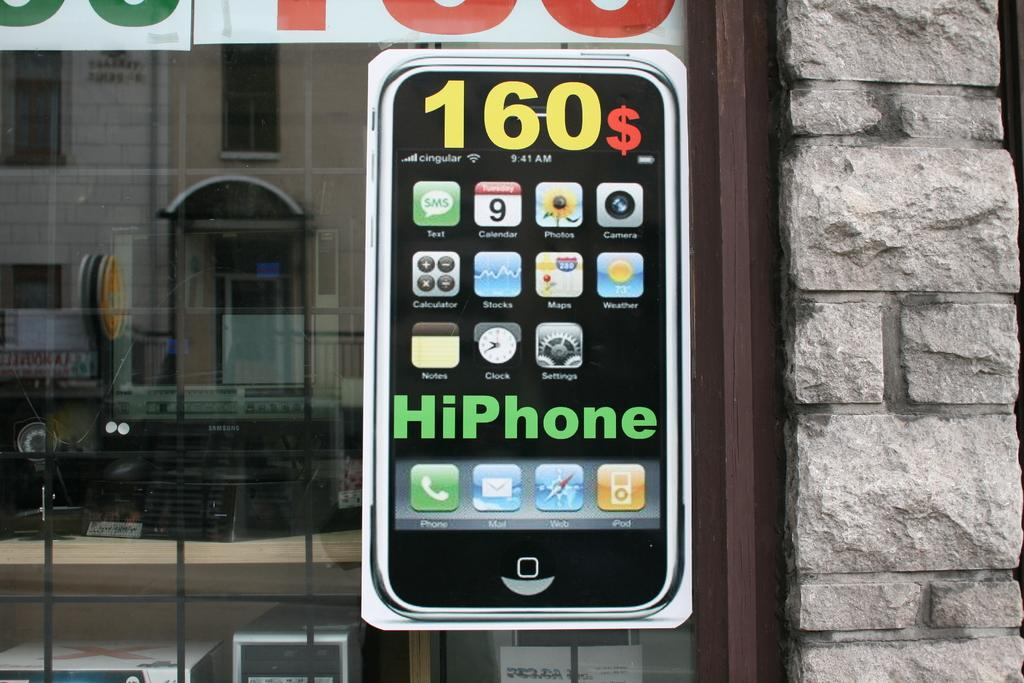<image>
Present a compact description of the photo's key features. HiPhones are being sold for $160 at this shop. 